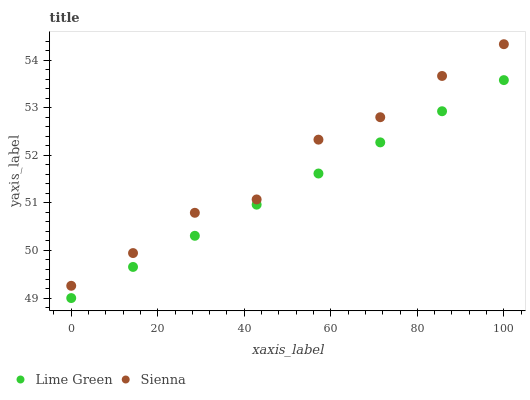Does Lime Green have the minimum area under the curve?
Answer yes or no. Yes. Does Sienna have the maximum area under the curve?
Answer yes or no. Yes. Does Lime Green have the maximum area under the curve?
Answer yes or no. No. Is Lime Green the smoothest?
Answer yes or no. Yes. Is Sienna the roughest?
Answer yes or no. Yes. Is Lime Green the roughest?
Answer yes or no. No. Does Lime Green have the lowest value?
Answer yes or no. Yes. Does Sienna have the highest value?
Answer yes or no. Yes. Does Lime Green have the highest value?
Answer yes or no. No. Is Lime Green less than Sienna?
Answer yes or no. Yes. Is Sienna greater than Lime Green?
Answer yes or no. Yes. Does Lime Green intersect Sienna?
Answer yes or no. No. 